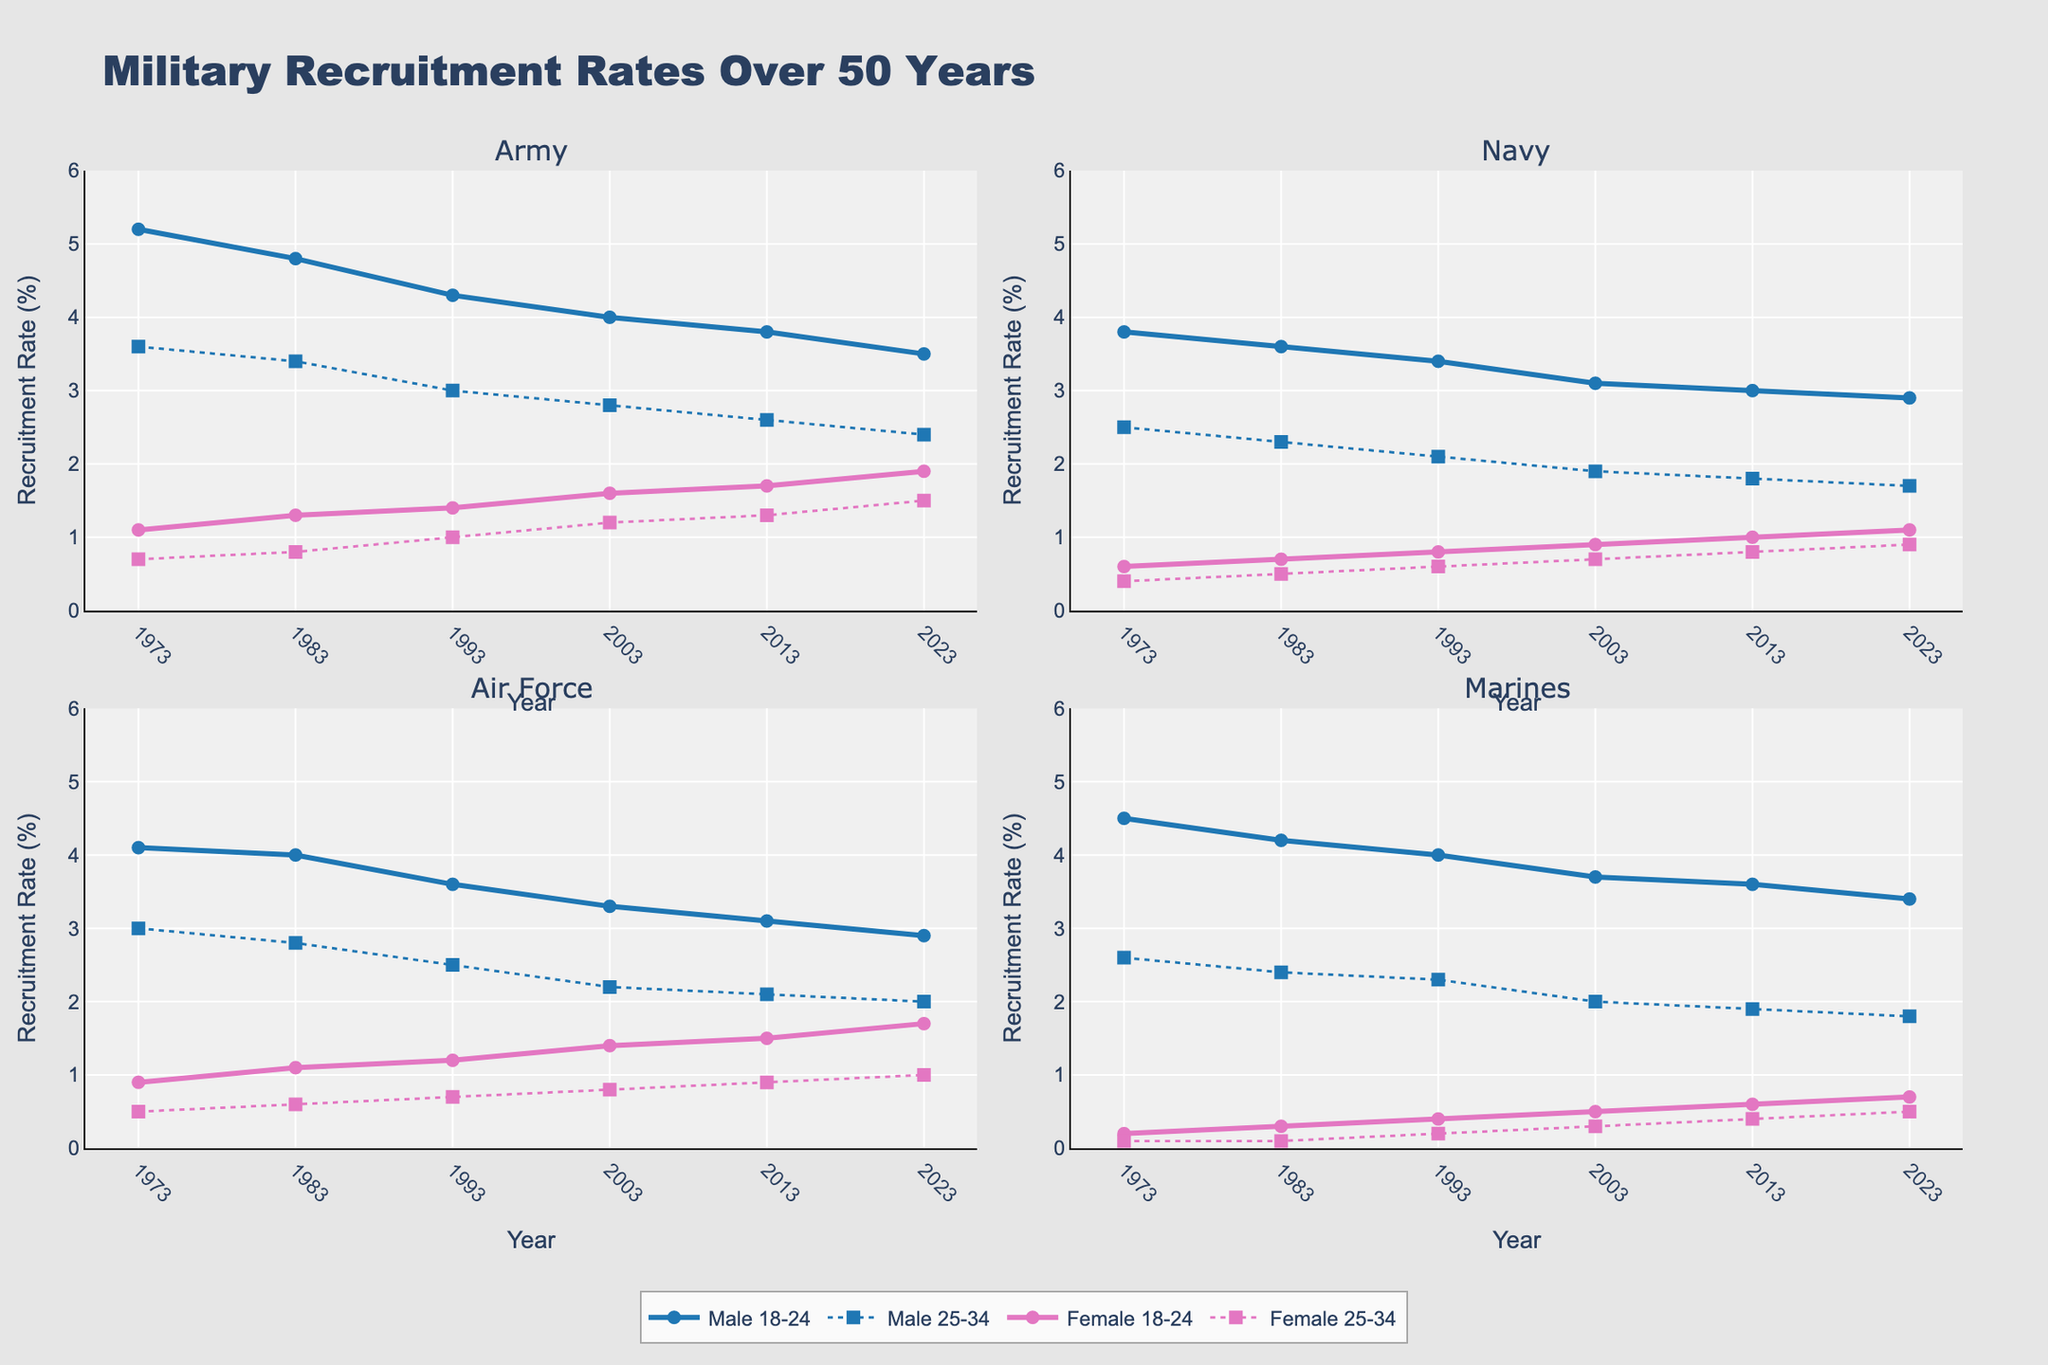What's the title of the figure? The title is usually located at the top of a figure. By looking at the top, you will see the text "Military Recruitment Rates Over 50 Years".
Answer: Military Recruitment Rates Over 50 Years How does the recruitment rate for 18-24 year old males in the Navy change from 1973 to 2023? To answer this, look at the subplot for the Navy and find the line representing 18-24 year old males. Follow the line from the 1973 point to the 2023 point.
Answer: Decreases from 3.8% to 2.9% Which age group has a higher recruitment rate for males in the Marines in 1983? Check the subplot for the Marines and compare the lines representing the 18-24 and 25-34 year old males for the year 1983. The line for 18-24 year old males is higher.
Answer: 18-24 year olds What's the difference in recruitment rates between 18-24 year old males and females in the Air Force in 1993? For the Air Force subplot, find the points for 18-24 year old males and females in 1993. The male rate is 3.6%, and the female rate is 1.2%. The difference is 3.6% - 1.2%.
Answer: 2.4% Describe the trend in recruitment rates for 25-34 year old females in the Army from 1973 to 2023. Look at the line representing 25-34 year old females in the Army subplot across the years. The line starts at 0.7% in 1973 and generally increases to 1.5% in 2023.
Answer: Generally increasing In which branch did the recruitment rate for 18-24 year old females see the greatest increase from 1973 to 2023? Find the increases for 18-24 year old females in each branch over these years. Calculate the increases and compare. The Army had an increase from 1.1% to 1.9%.
Answer: Army Compare the recruitment rates of 18-24 year old females and males in the Navy in 2003. Locate the 2003 points for both 18-24 year old females and males in the Navy. The female rate is 0.9%, and the male rate is 3.1%.
Answer: Males have a higher rate What's the average recruitment rate of 25-34 year old males in the Air Force across all the years shown? Find the recruitment rates for 25-34 year old males in the Air Force from 1973 to 2023. Sum these rates: 3.0 + 2.8 + 2.5 + 2.2 + 2.1 + 2.0 = 14.6. There are 6 years, so average is 14.6 / 6.
Answer: 2.43% Which branch shows the lowest overall recruitment rate for 25-34 year old females in 2023? Check the recruitment rate for 25-34 year old females in each branch in 2023. The rates are Army: 1.5%, Navy: 0.9%, Air Force: 1.0%, Marines: 0.5%. The Marines have the lowest rate.
Answer: Marines 